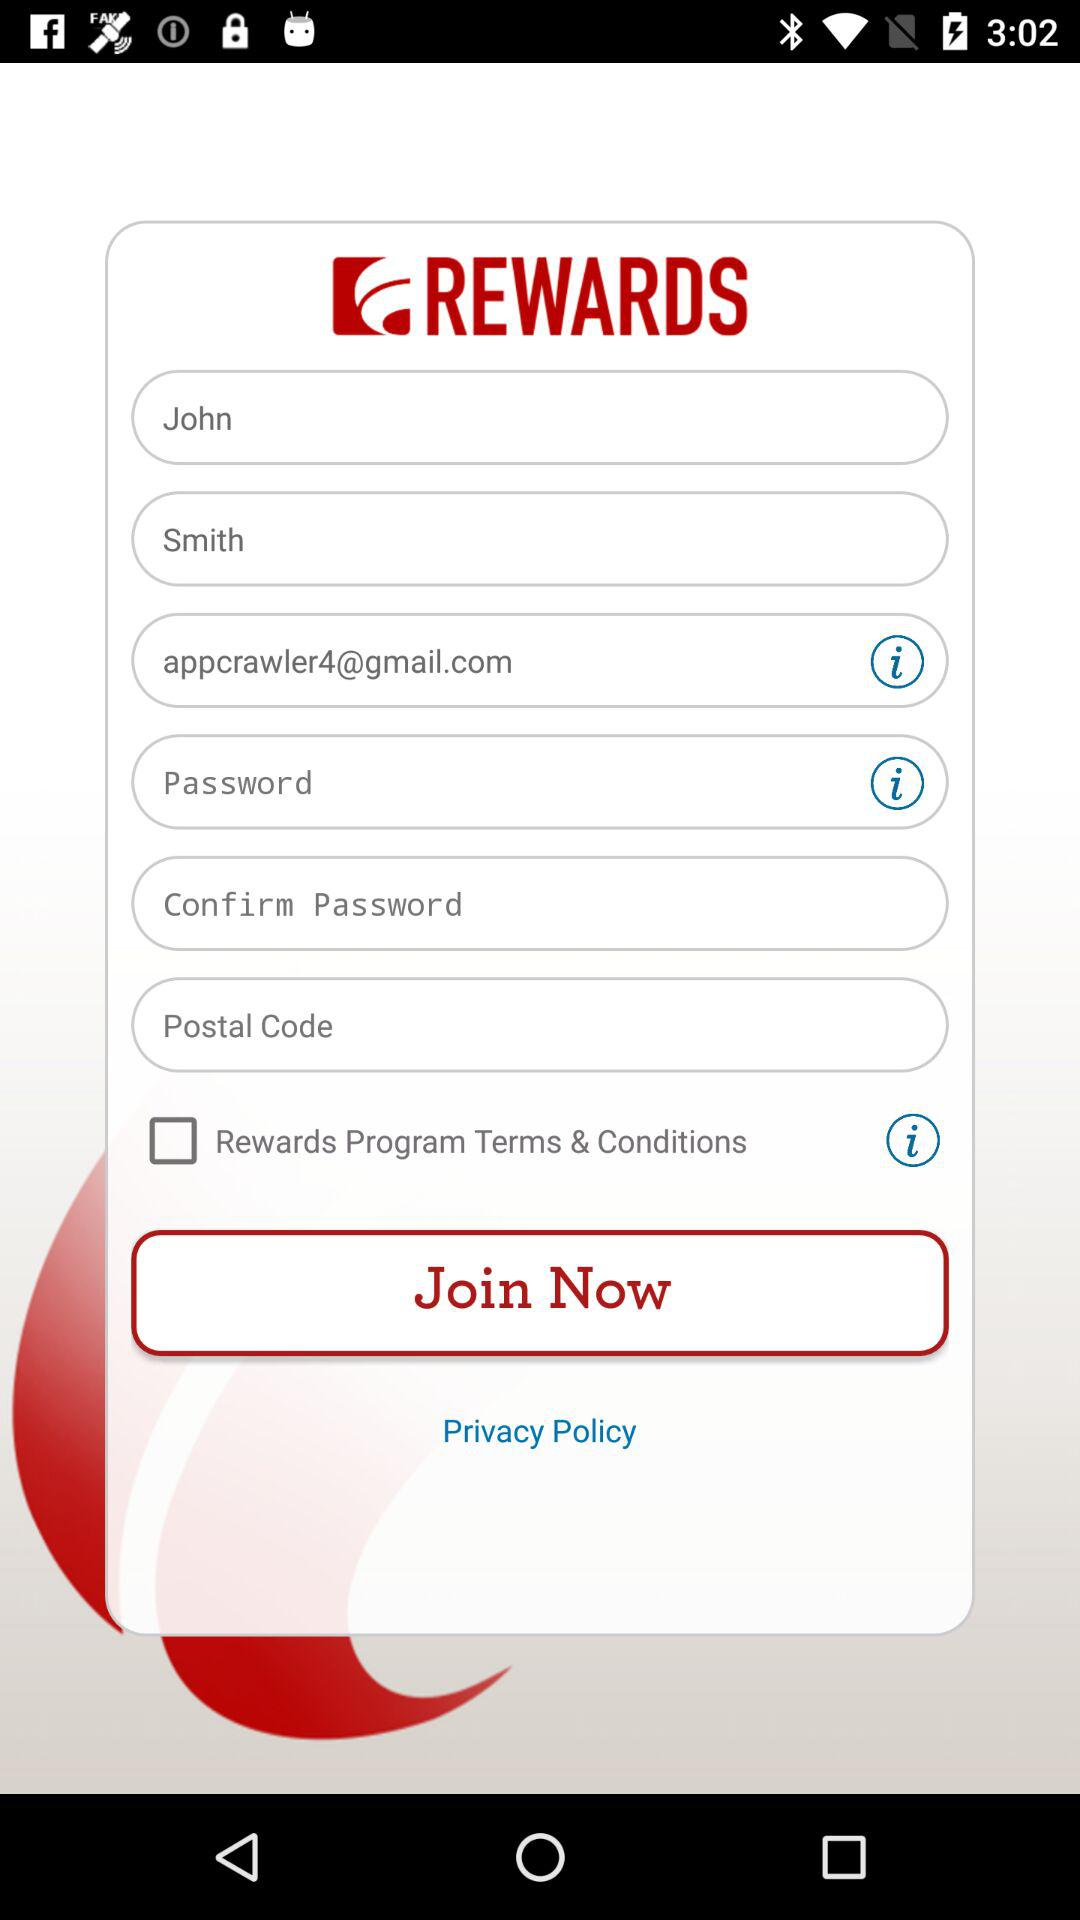What is the status of "Rewards Program Terms & Conditions"? The status of "Rewards Program Terms & Conditions" is "off". 